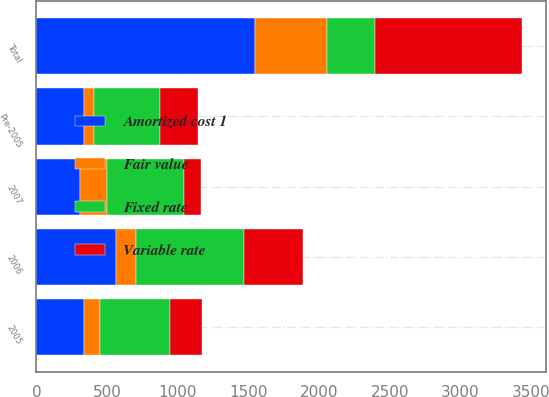Convert chart. <chart><loc_0><loc_0><loc_500><loc_500><stacked_bar_chart><ecel><fcel>2007<fcel>2006<fcel>2005<fcel>Pre-2005<fcel>Total<nl><fcel>Variable rate<fcel>124<fcel>420<fcel>226<fcel>268<fcel>1038<nl><fcel>Fair value<fcel>187<fcel>143<fcel>112<fcel>68<fcel>510<nl><fcel>Amortized cost 1<fcel>311<fcel>563<fcel>338<fcel>336<fcel>1548<nl><fcel>Fixed rate<fcel>546<fcel>762<fcel>496<fcel>472<fcel>338<nl></chart> 